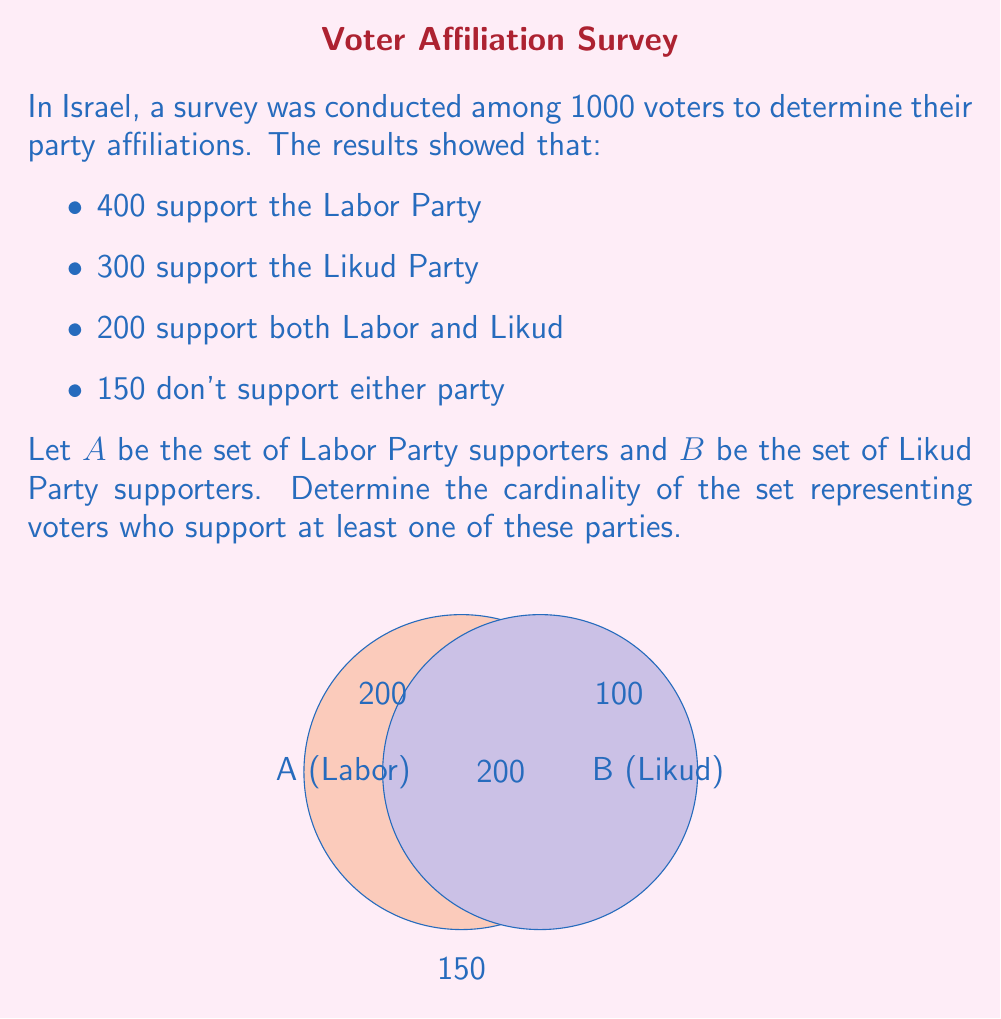Can you answer this question? To solve this problem, we'll use the principle of inclusion-exclusion:

1) Let's define our sets:
   A = set of Labor Party supporters
   B = set of Likud Party supporters

2) We're asked to find $|A \cup B|$, which represents the number of voters supporting at least one party.

3) The principle of inclusion-exclusion states:
   $$|A \cup B| = |A| + |B| - |A \cap B|$$

4) From the given information:
   $|A| = 400$ (Labor supporters)
   $|B| = 300$ (Likud supporters)
   $|A \cap B| = 200$ (supporters of both parties)

5) Substituting these values into our equation:
   $$|A \cup B| = 400 + 300 - 200 = 500$$

6) To verify, we can check the total:
   500 (support at least one party) + 150 (support neither) = 650
   This equals 1000 - 350 = 650, where 350 is the number counted twice (200 in both parties + 150 in neither).

Therefore, the cardinality of the set representing voters who support at least one of these parties is 500.
Answer: 500 